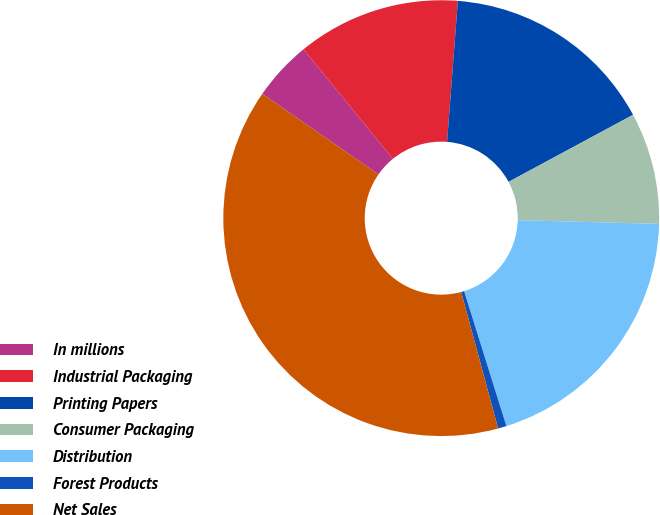<chart> <loc_0><loc_0><loc_500><loc_500><pie_chart><fcel>In millions<fcel>Industrial Packaging<fcel>Printing Papers<fcel>Consumer Packaging<fcel>Distribution<fcel>Forest Products<fcel>Net Sales<nl><fcel>4.45%<fcel>12.1%<fcel>15.92%<fcel>8.28%<fcel>19.75%<fcel>0.63%<fcel>38.87%<nl></chart> 